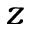Convert formula to latex. <formula><loc_0><loc_0><loc_500><loc_500>z</formula> 